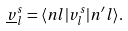<formula> <loc_0><loc_0><loc_500><loc_500>\underline { v } _ { l } ^ { s } = \langle n l | v _ { l } ^ { s } | n ^ { \prime } l \rangle .</formula> 